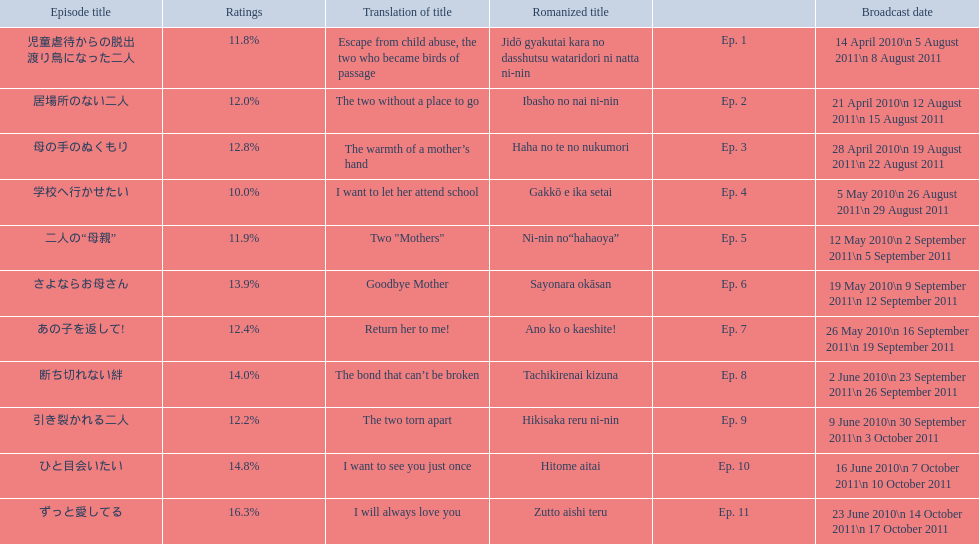What is the name of epsiode 8? 断ち切れない絆. What were this episodes ratings? 14.0%. 